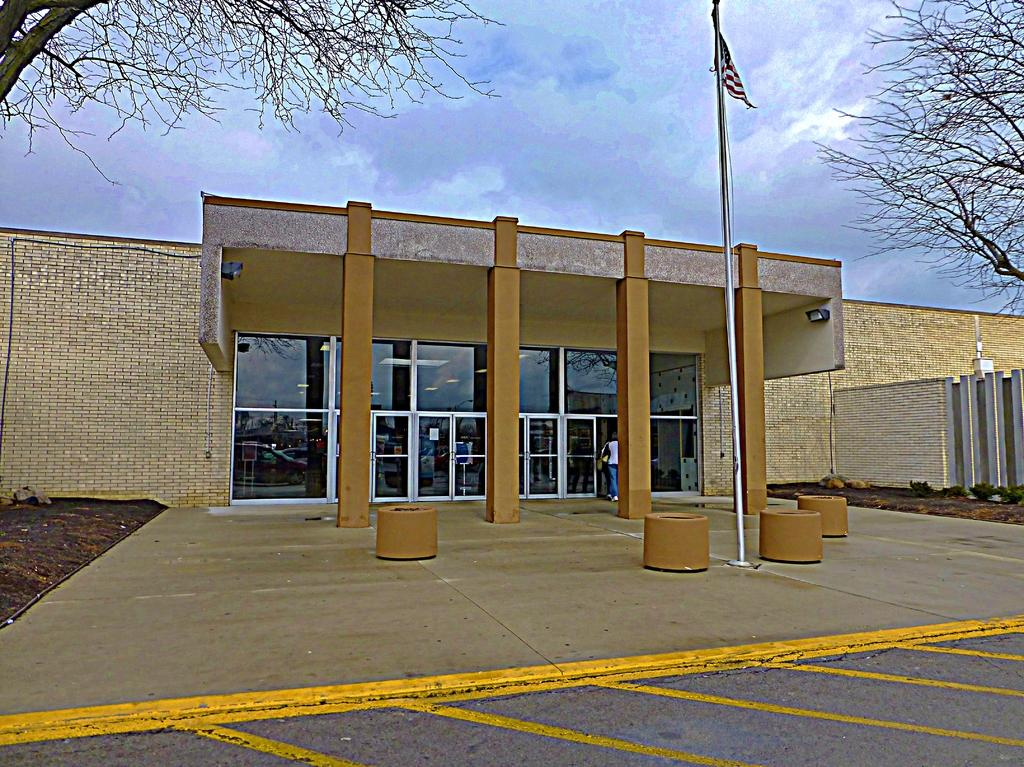What structure is the main focus of the image? There is a building in the image. What is the person in the image doing? A person is walking into the building. What is located in front of the building? There is a flag in front of the building. What can be seen in the background of the image? There are trees and the sky visible in the background of the image. What type of cup is being copied by the person in the image? There is no person copying a cup in the image; the person is walking into the building. 